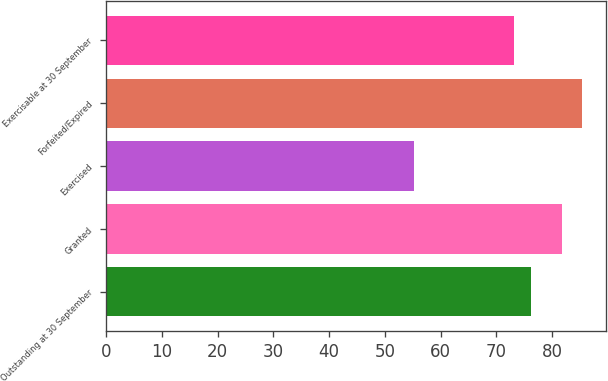Convert chart to OTSL. <chart><loc_0><loc_0><loc_500><loc_500><bar_chart><fcel>Outstanding at 30 September<fcel>Granted<fcel>Exercised<fcel>Forfeited/Expired<fcel>Exercisable at 30 September<nl><fcel>76.25<fcel>81.76<fcel>55.17<fcel>85.37<fcel>73.23<nl></chart> 